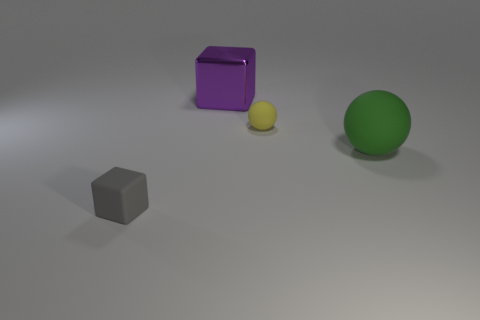Are there any other things that are the same material as the large purple thing?
Offer a terse response. No. Is there a small thing of the same color as the big metallic object?
Make the answer very short. No. Is the material of the green sphere the same as the purple object?
Ensure brevity in your answer.  No. What number of small matte balls are in front of the purple shiny block?
Your response must be concise. 1. The object that is both on the left side of the yellow matte object and behind the big green matte sphere is made of what material?
Offer a terse response. Metal. How many green rubber spheres have the same size as the purple block?
Give a very brief answer. 1. What is the color of the small thing behind the small gray matte block on the left side of the large green matte ball?
Make the answer very short. Yellow. Is there a purple block?
Give a very brief answer. Yes. Does the large metal object have the same shape as the big rubber object?
Provide a succinct answer. No. There is a large green sphere in front of the small yellow rubber sphere; what number of green objects are in front of it?
Ensure brevity in your answer.  0. 